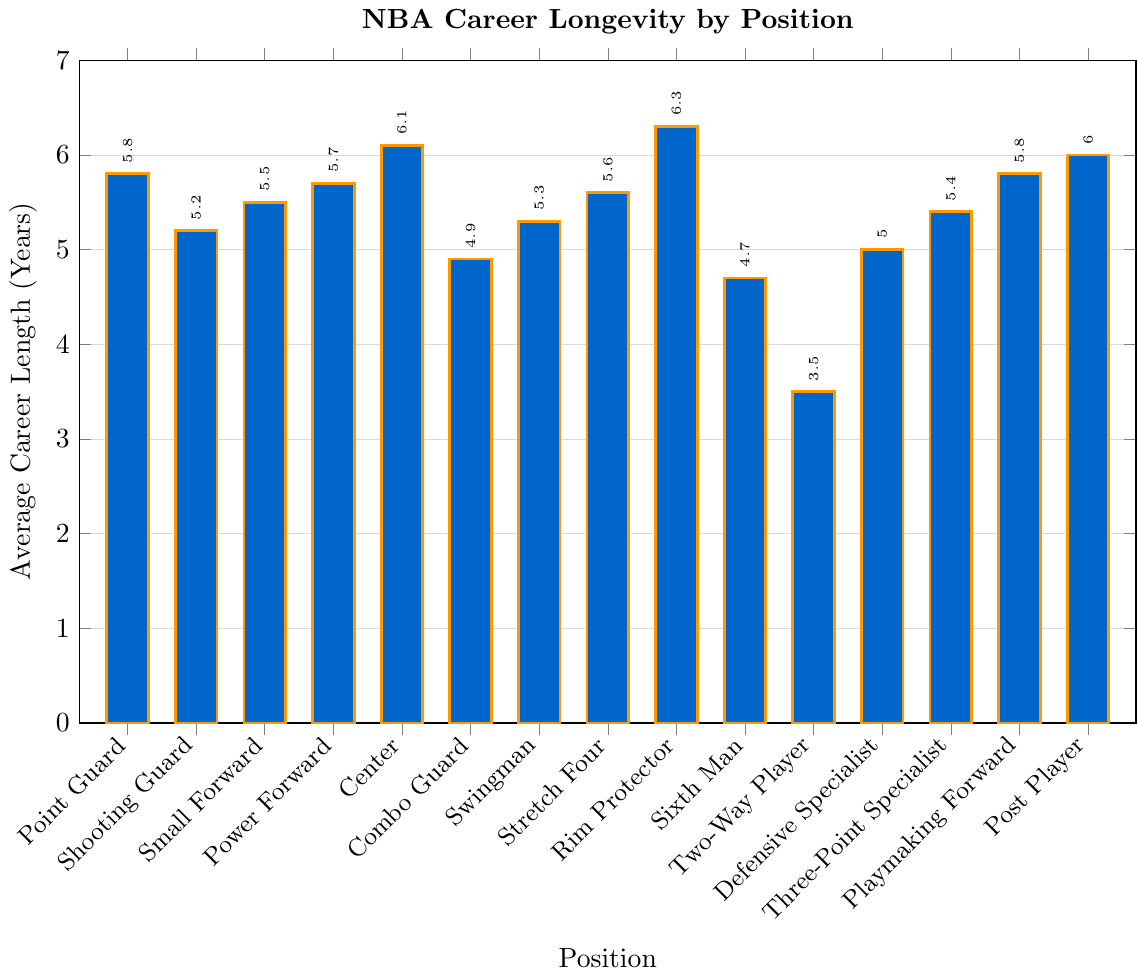Which position has the longest average career length? The tallest bar represents the Rim Protector position, which has the highest average career length.
Answer: Rim Protector Which two positions have the shortest average career lengths? The shortest bars represent the Two-Way Player and Sixth Man positions, respectively.
Answer: Two-Way Player and Sixth Man What's the difference in average career length between a Point Guard and a Center? The average career length for a Center is 6.1 years and for a Point Guard is 5.8 years. Subtracting these gives 6.1 - 5.8 = 0.3 years.
Answer: 0.3 years How does the average career length of a Combo Guard compare to a Three-Point Specialist? The bar representing Three-Point Specialist (5.4 years) is taller than the one representing Combo Guard (4.9 years).
Answer: Three-Point Specialist is longer What is the median average career length of all positions listed? Arrange the career lengths in ascending order: 3.5, 4.7, 4.9, 5.0, 5.2, 5.3, 5.4, 5.5, 5.6, 5.7, 5.8, 5.8, 6.0, 6.1, 6.3. The median is the 8th value, which is 5.5.
Answer: 5.5 years Which is longer on average, a Defensive Specialist or a Playmaking Forward? The Playmaking Forward average is 5.8 years, while the Defensive Specialist is 5.0 years. Thus, Playmaking Forward is longer.
Answer: Playmaking Forward What is the total career length for the positions Power Forward, Center, and Post Player combined? Adding the career lengths: Power Forward (5.7) + Center (6.1) + Post Player (6.0) = 17.8 years.
Answer: 17.8 years How does the average career length of Stretch Four compare to Swingman? The bar for Stretch Four is slightly taller, indicating a longer average career length than Swingman. Stretch Four has 5.6 years while Swingman has 5.3 years.
Answer: Stretch Four is longer Which position has exactly the same average career length as the Point Guard? Both Point Guard and Playmaking Forward have bars at the same height, indicating an average career length of 5.8 years.
Answer: Playmaking Forward How does the average career length of the Sixth Man compare to the Combo Guard and Two-Way Player? The bars show that the Sixth Man (4.7 years) has a longer average career length than the Two-Way Player (3.5 years) but a shorter career length than the Combo Guard (4.9 years).
Answer: Longer than Two-Way Player, shorter than Combo Guard 